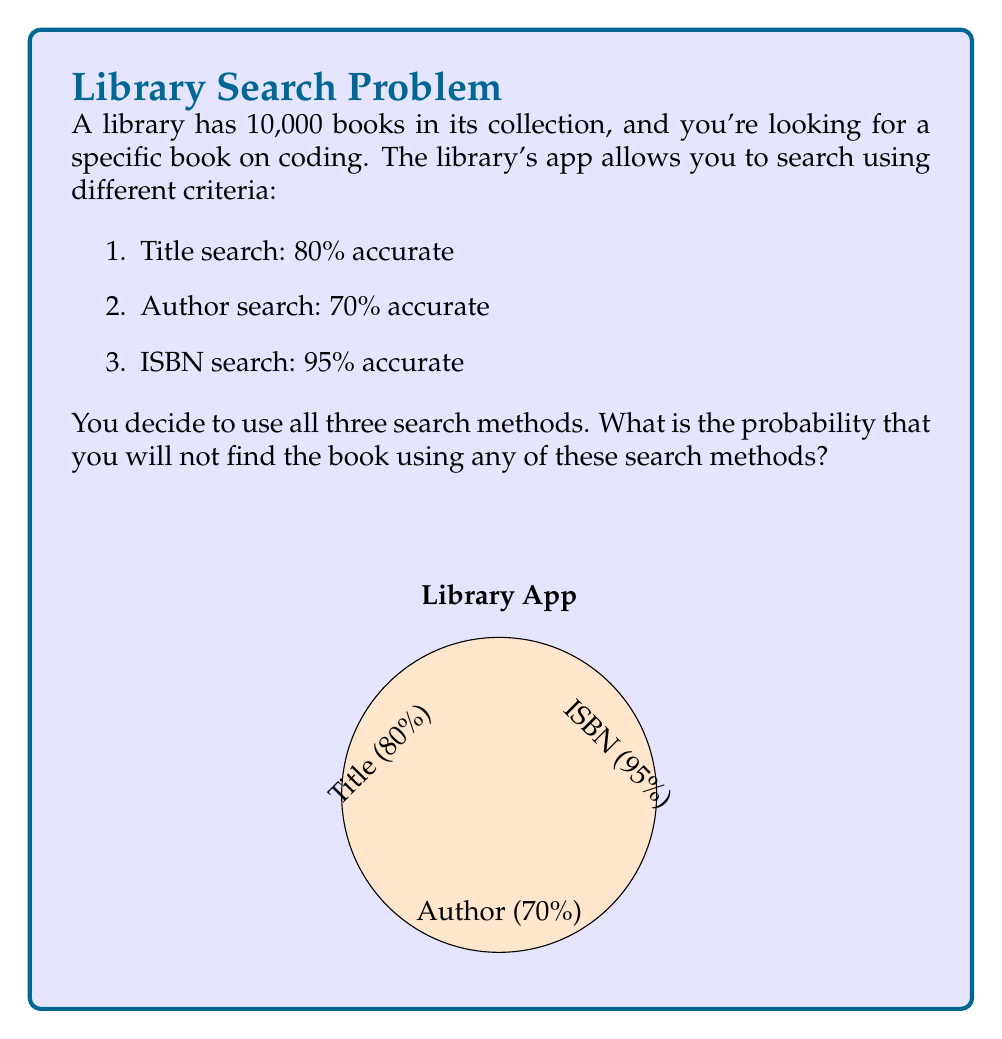Teach me how to tackle this problem. Let's approach this step-by-step:

1) First, we need to calculate the probability of not finding the book for each search method:

   Title search: $1 - 0.80 = 0.20$ (20% chance of not finding)
   Author search: $1 - 0.70 = 0.30$ (30% chance of not finding)
   ISBN search: $1 - 0.95 = 0.05$ (5% chance of not finding)

2) Now, for the book to not be found at all, it must not be found in any of the three searches. Since these are independent events, we multiply the probabilities:

   $$P(\text{not found}) = 0.20 \times 0.30 \times 0.05$$

3) Let's calculate this:

   $$P(\text{not found}) = 0.20 \times 0.30 \times 0.05 = 0.003$$

4) To convert to a percentage, we multiply by 100:

   $$0.003 \times 100 = 0.3\%$$

Therefore, there is a 0.3% chance that you will not find the book using any of these search methods.
Answer: $0.3\%$ 